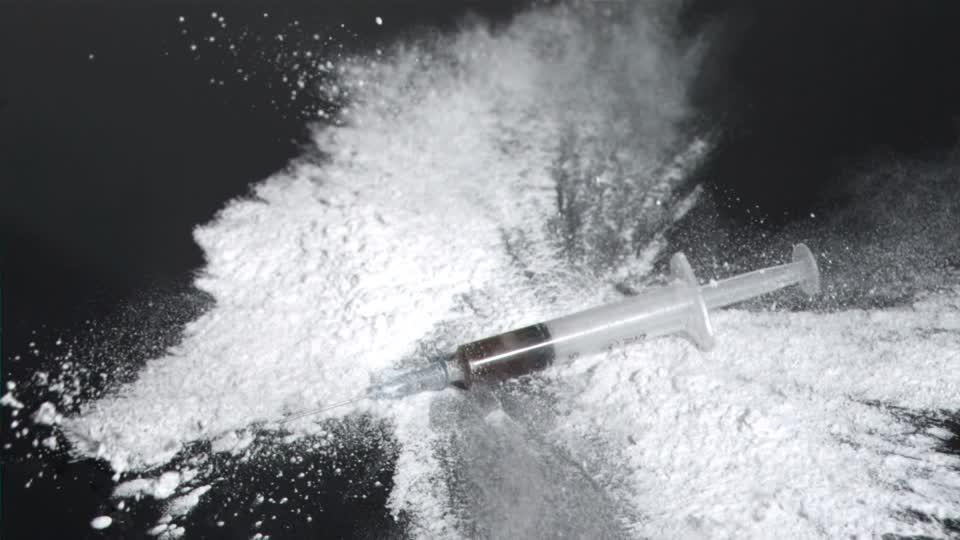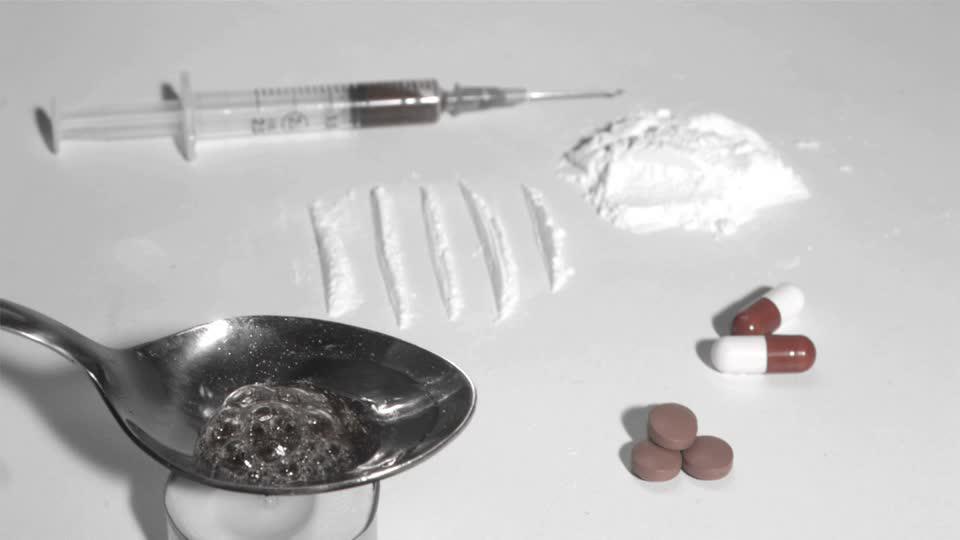The first image is the image on the left, the second image is the image on the right. Assess this claim about the two images: "There are two needles and one spoon.". Correct or not? Answer yes or no. Yes. The first image is the image on the left, the second image is the image on the right. Analyze the images presented: Is the assertion "There are two syringes and one spoon." valid? Answer yes or no. Yes. 